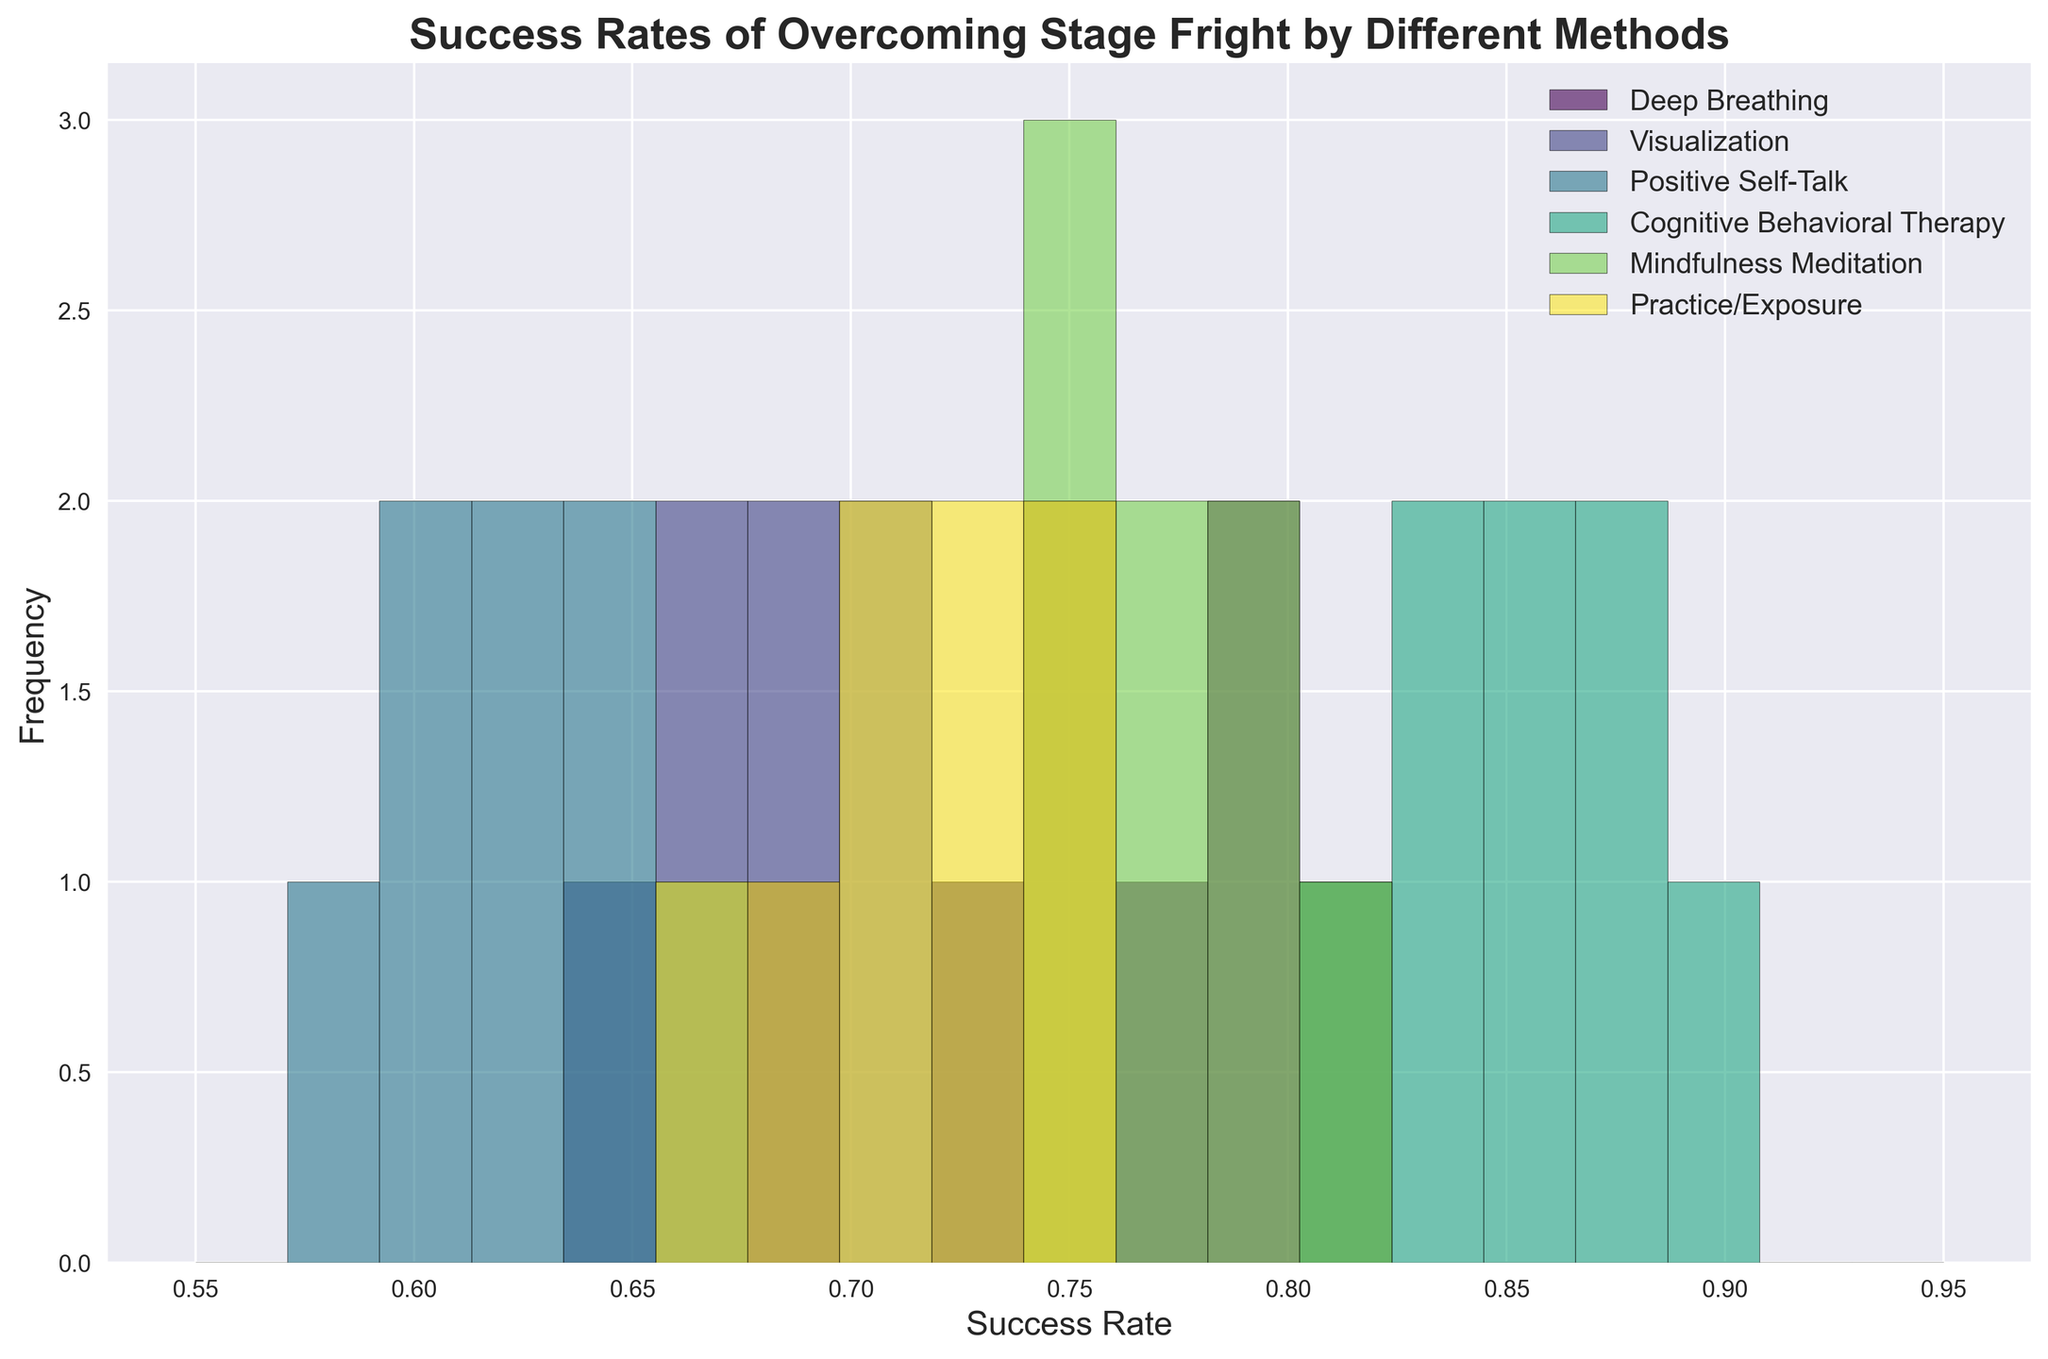What method has the highest average success rate? Cognitive Behavioral Therapy has the highest average success rate as its histogram bars are positioned further to the right than those of other methods.
Answer: Cognitive Behavioral Therapy Which method shows the most variability in success rates? Deep Breathing shows the most variability because the spread of its histogram bars covers a wider range compared to the other methods.
Answer: Deep Breathing Is there any overlap in success rates between Deep Breathing and Mindfulness Meditation? Yes, both Deep Breathing and Mindfulness Meditation histograms overlap around the 0.74 to 0.80 success rate range.
Answer: Yes Which method has the least frequency at a success rate of around 0.65? Cognitive Behavioral Therapy has the least frequency at a 0.65 success rate as its bars do not extend to that value.
Answer: Cognitive Behavioral Therapy Does Visualization have higher or lower success rates compared to Positive Self-Talk? Visualization generally has slightly higher success rates than Positive Self-Talk, as its histogram bars are placed a bit to the right of Positive Self-Talk bars.
Answer: Higher What is the range of success rates for Practice/Exposure? The range of success rates for Practice/Exposure is from 0.67 to 0.75, indicated by the spread of its histogram bars.
Answer: 0.67 - 0.75 What methods have a peak frequency around a success rate of 0.75? Deep Breathing and Mindfulness Meditation both have peak frequencies around a 0.75 success rate, shown by the higher bars at this rate in their respective histograms.
Answer: Deep Breathing, Mindfulness Meditation How does the frequency of Cognitive Behavioral Therapy success rates compare at 0.84 and 0.88? The frequencies at 0.84 and 0.88 success rates for Cognitive Behavioral Therapy are both high, as indicated by the tall bars at these points in its histogram.
Answer: Both high Which method appears to be the least effective based on the histogram? Positive Self-Talk appears to be the least effective as its histogram bars are mostly positioned on the lower end of the success rate spectrum compared to other methods.
Answer: Positive Self-Talk 